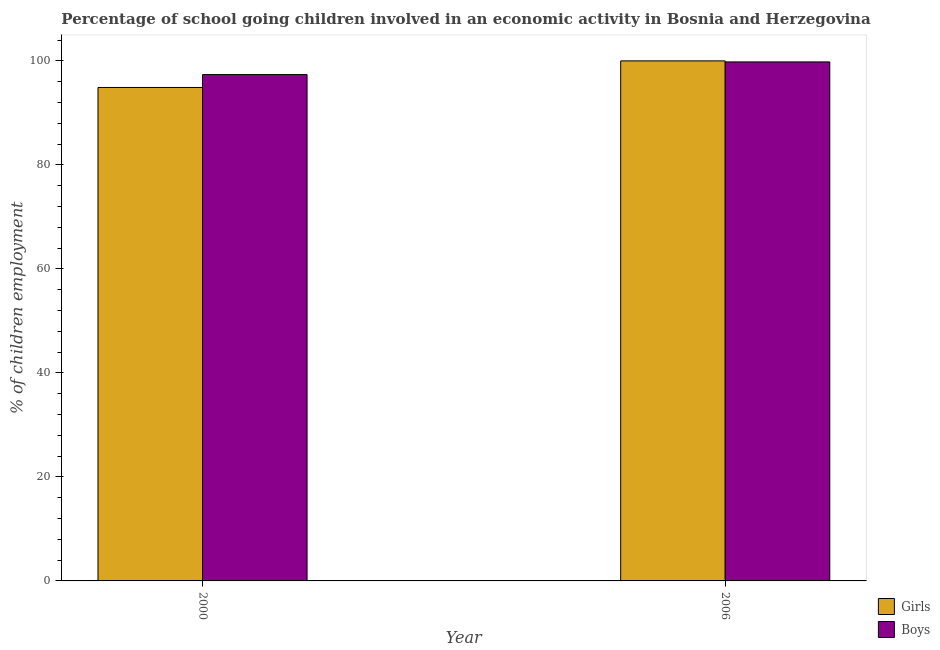How many groups of bars are there?
Offer a very short reply. 2. Are the number of bars per tick equal to the number of legend labels?
Your answer should be very brief. Yes. What is the label of the 2nd group of bars from the left?
Give a very brief answer. 2006. In how many cases, is the number of bars for a given year not equal to the number of legend labels?
Offer a terse response. 0. What is the percentage of school going boys in 2000?
Make the answer very short. 97.37. Across all years, what is the maximum percentage of school going boys?
Ensure brevity in your answer.  99.8. Across all years, what is the minimum percentage of school going girls?
Make the answer very short. 94.89. In which year was the percentage of school going boys minimum?
Give a very brief answer. 2000. What is the total percentage of school going girls in the graph?
Ensure brevity in your answer.  194.89. What is the difference between the percentage of school going boys in 2000 and that in 2006?
Ensure brevity in your answer.  -2.43. What is the difference between the percentage of school going girls in 2006 and the percentage of school going boys in 2000?
Your response must be concise. 5.11. What is the average percentage of school going girls per year?
Offer a very short reply. 97.44. In the year 2000, what is the difference between the percentage of school going boys and percentage of school going girls?
Provide a short and direct response. 0. In how many years, is the percentage of school going girls greater than 88 %?
Your answer should be compact. 2. What is the ratio of the percentage of school going girls in 2000 to that in 2006?
Your answer should be compact. 0.95. Is the percentage of school going boys in 2000 less than that in 2006?
Ensure brevity in your answer.  Yes. In how many years, is the percentage of school going girls greater than the average percentage of school going girls taken over all years?
Offer a terse response. 1. What does the 2nd bar from the left in 2000 represents?
Give a very brief answer. Boys. What does the 1st bar from the right in 2000 represents?
Ensure brevity in your answer.  Boys. Are all the bars in the graph horizontal?
Your response must be concise. No. What is the difference between two consecutive major ticks on the Y-axis?
Ensure brevity in your answer.  20. Are the values on the major ticks of Y-axis written in scientific E-notation?
Your answer should be compact. No. Does the graph contain any zero values?
Provide a succinct answer. No. How are the legend labels stacked?
Offer a terse response. Vertical. What is the title of the graph?
Provide a succinct answer. Percentage of school going children involved in an economic activity in Bosnia and Herzegovina. What is the label or title of the X-axis?
Your answer should be compact. Year. What is the label or title of the Y-axis?
Your response must be concise. % of children employment. What is the % of children employment of Girls in 2000?
Make the answer very short. 94.89. What is the % of children employment in Boys in 2000?
Your answer should be very brief. 97.37. What is the % of children employment in Girls in 2006?
Ensure brevity in your answer.  100. What is the % of children employment in Boys in 2006?
Make the answer very short. 99.8. Across all years, what is the maximum % of children employment in Boys?
Offer a very short reply. 99.8. Across all years, what is the minimum % of children employment in Girls?
Provide a succinct answer. 94.89. Across all years, what is the minimum % of children employment in Boys?
Keep it short and to the point. 97.37. What is the total % of children employment of Girls in the graph?
Your answer should be compact. 194.89. What is the total % of children employment in Boys in the graph?
Provide a short and direct response. 197.17. What is the difference between the % of children employment of Girls in 2000 and that in 2006?
Provide a succinct answer. -5.11. What is the difference between the % of children employment of Boys in 2000 and that in 2006?
Give a very brief answer. -2.43. What is the difference between the % of children employment of Girls in 2000 and the % of children employment of Boys in 2006?
Make the answer very short. -4.91. What is the average % of children employment in Girls per year?
Your answer should be compact. 97.44. What is the average % of children employment of Boys per year?
Offer a terse response. 98.58. In the year 2000, what is the difference between the % of children employment of Girls and % of children employment of Boys?
Your answer should be compact. -2.48. In the year 2006, what is the difference between the % of children employment in Girls and % of children employment in Boys?
Make the answer very short. 0.2. What is the ratio of the % of children employment in Girls in 2000 to that in 2006?
Make the answer very short. 0.95. What is the ratio of the % of children employment of Boys in 2000 to that in 2006?
Your answer should be compact. 0.98. What is the difference between the highest and the second highest % of children employment of Girls?
Offer a terse response. 5.11. What is the difference between the highest and the second highest % of children employment in Boys?
Your answer should be very brief. 2.43. What is the difference between the highest and the lowest % of children employment of Girls?
Make the answer very short. 5.11. What is the difference between the highest and the lowest % of children employment in Boys?
Make the answer very short. 2.43. 